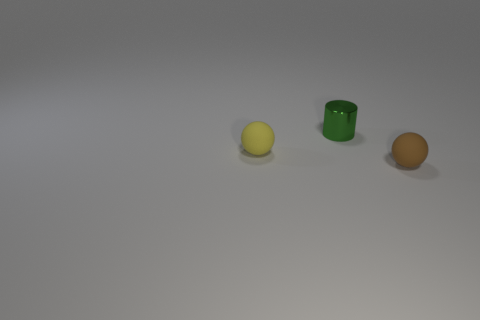Add 1 small red things. How many objects exist? 4 Subtract 1 balls. How many balls are left? 1 Subtract 0 gray balls. How many objects are left? 3 Subtract all cylinders. How many objects are left? 2 Subtract all green cylinders. Subtract all tiny yellow matte balls. How many objects are left? 1 Add 2 tiny green shiny cylinders. How many tiny green shiny cylinders are left? 3 Add 2 matte balls. How many matte balls exist? 4 